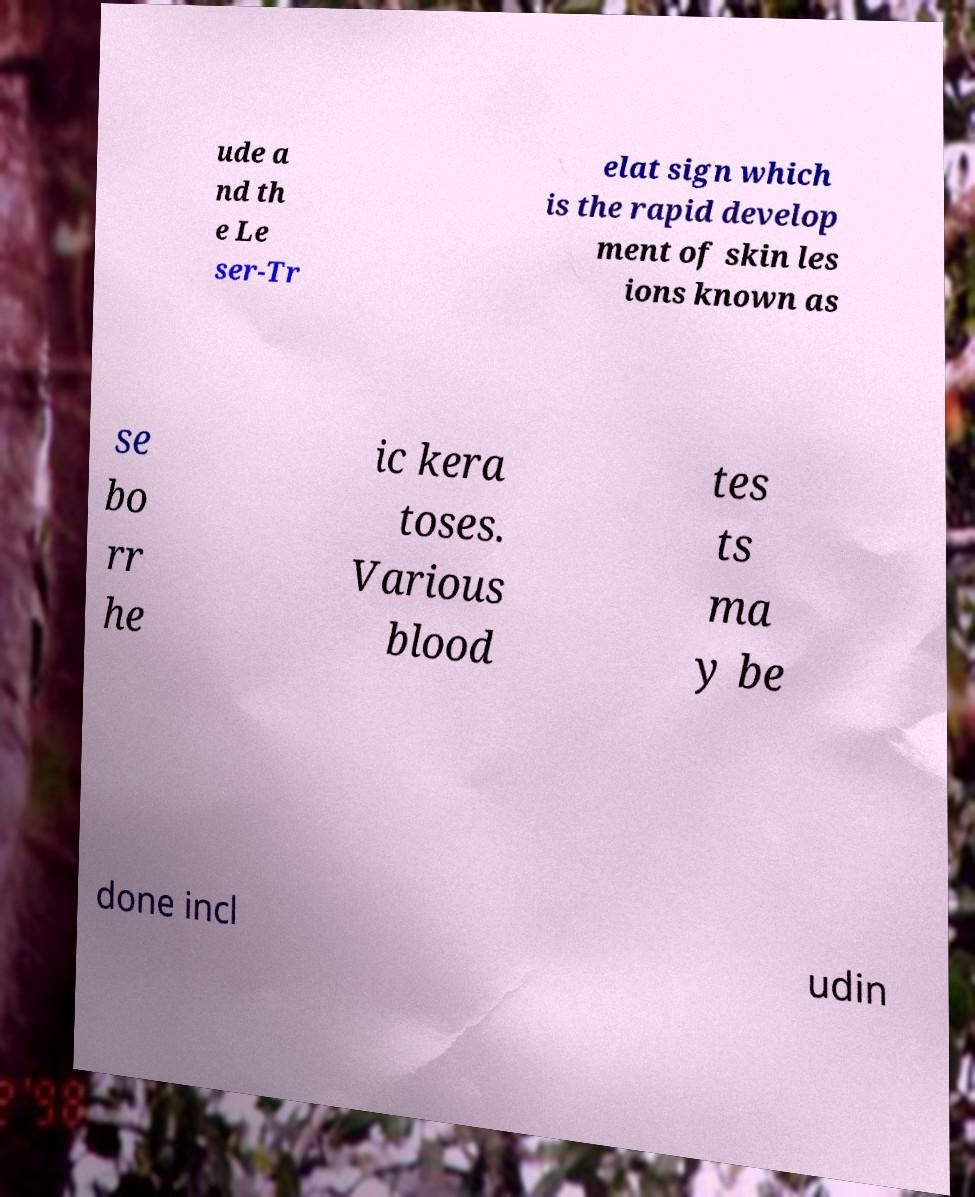Please identify and transcribe the text found in this image. ude a nd th e Le ser-Tr elat sign which is the rapid develop ment of skin les ions known as se bo rr he ic kera toses. Various blood tes ts ma y be done incl udin 